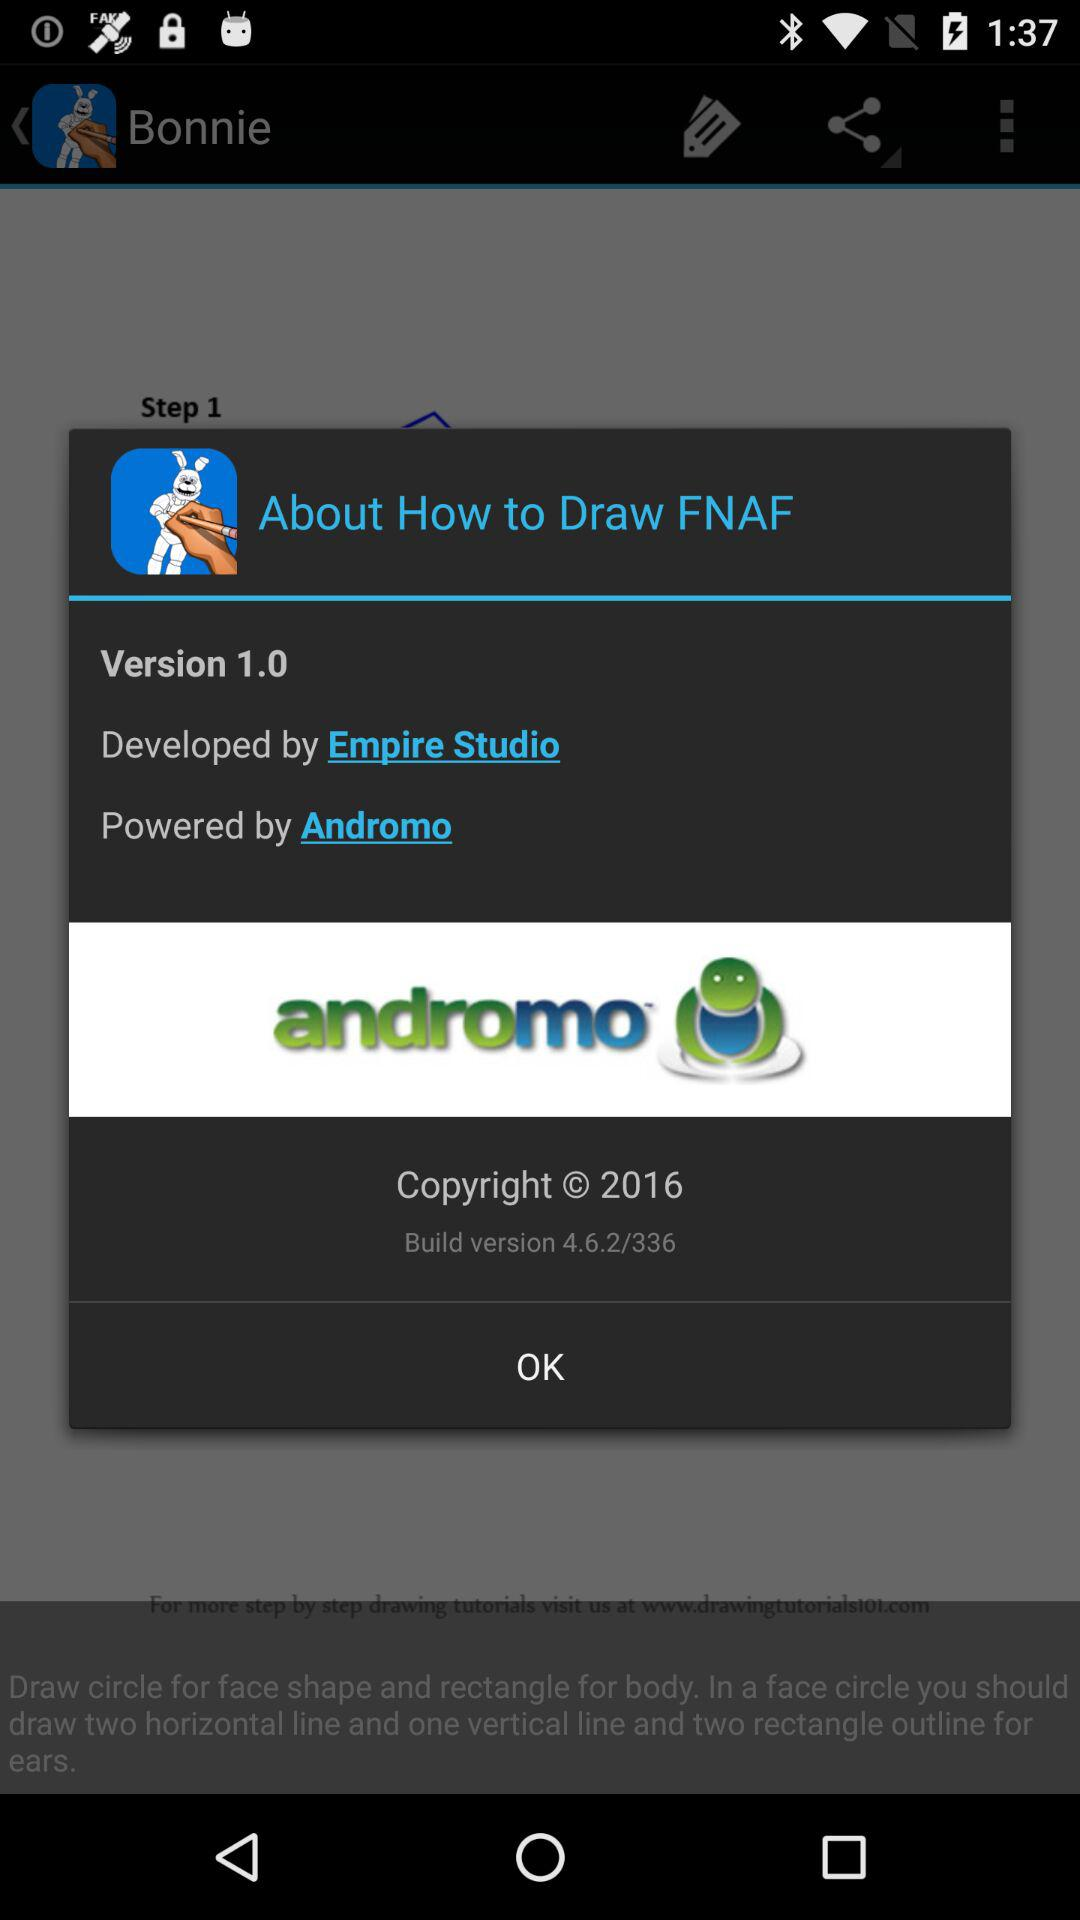Who has developed "How to Draw FNAF"? "How to Draw FNAF" is developed by Empire Studio. 